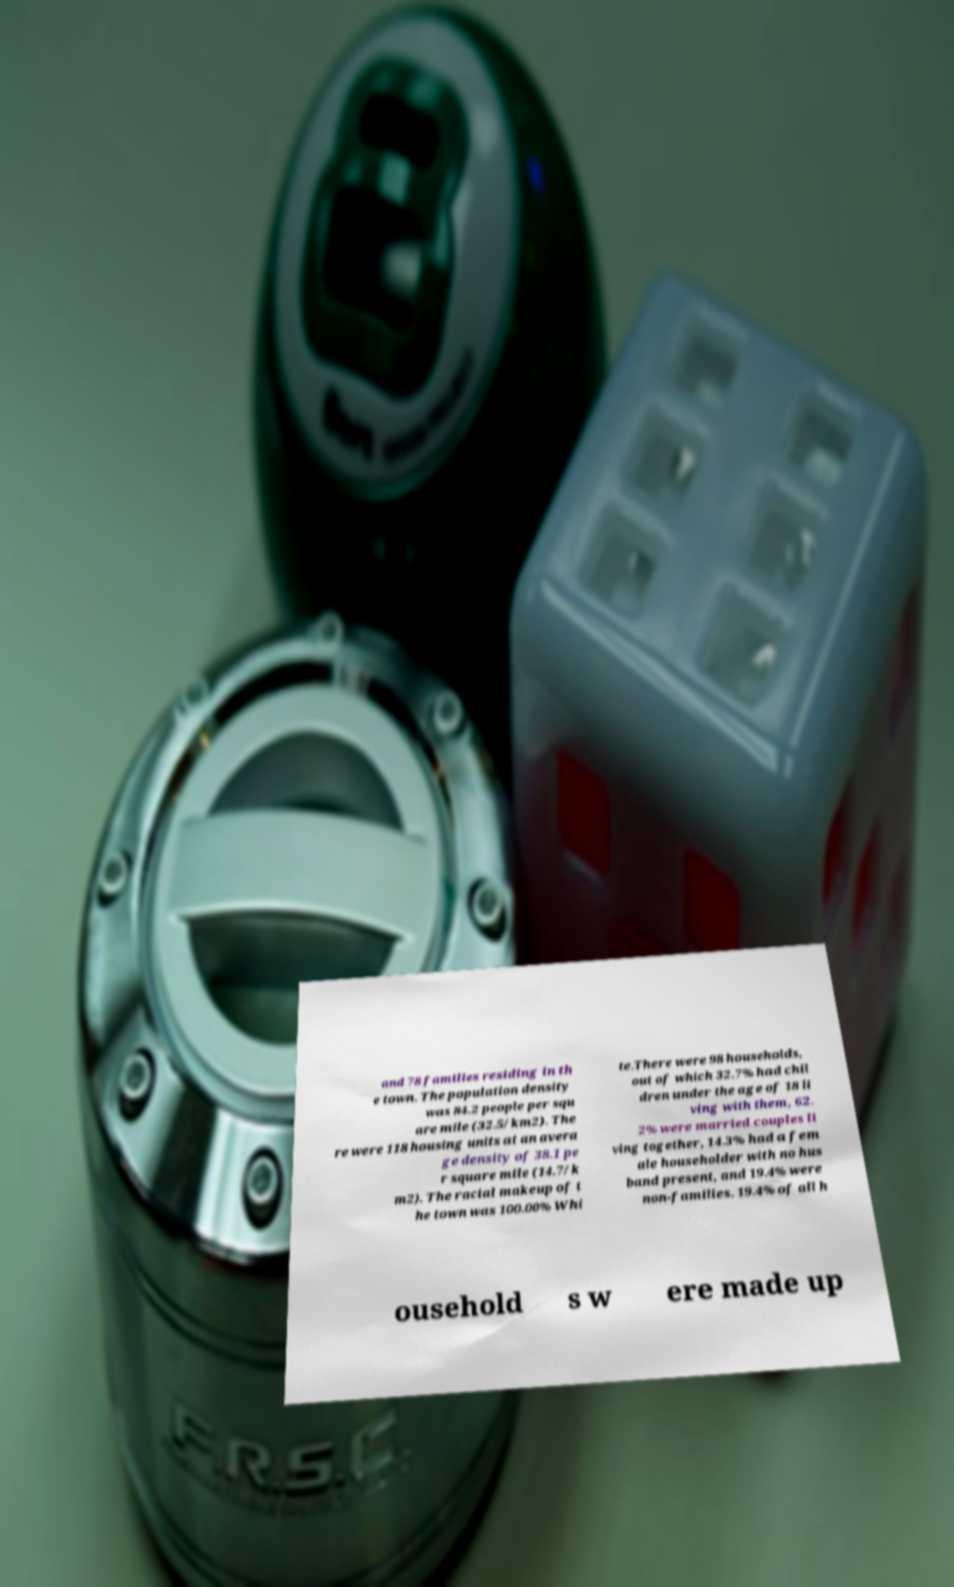There's text embedded in this image that I need extracted. Can you transcribe it verbatim? and 78 families residing in th e town. The population density was 84.2 people per squ are mile (32.5/km2). The re were 118 housing units at an avera ge density of 38.1 pe r square mile (14.7/k m2). The racial makeup of t he town was 100.00% Whi te.There were 98 households, out of which 32.7% had chil dren under the age of 18 li ving with them, 62. 2% were married couples li ving together, 14.3% had a fem ale householder with no hus band present, and 19.4% were non-families. 19.4% of all h ousehold s w ere made up 